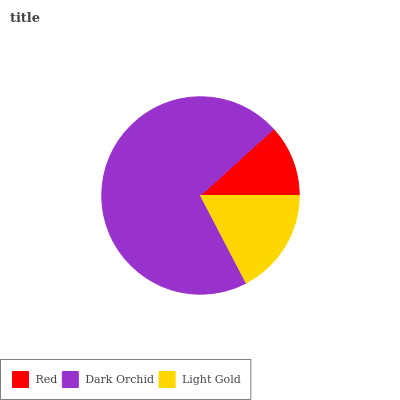Is Red the minimum?
Answer yes or no. Yes. Is Dark Orchid the maximum?
Answer yes or no. Yes. Is Light Gold the minimum?
Answer yes or no. No. Is Light Gold the maximum?
Answer yes or no. No. Is Dark Orchid greater than Light Gold?
Answer yes or no. Yes. Is Light Gold less than Dark Orchid?
Answer yes or no. Yes. Is Light Gold greater than Dark Orchid?
Answer yes or no. No. Is Dark Orchid less than Light Gold?
Answer yes or no. No. Is Light Gold the high median?
Answer yes or no. Yes. Is Light Gold the low median?
Answer yes or no. Yes. Is Dark Orchid the high median?
Answer yes or no. No. Is Dark Orchid the low median?
Answer yes or no. No. 